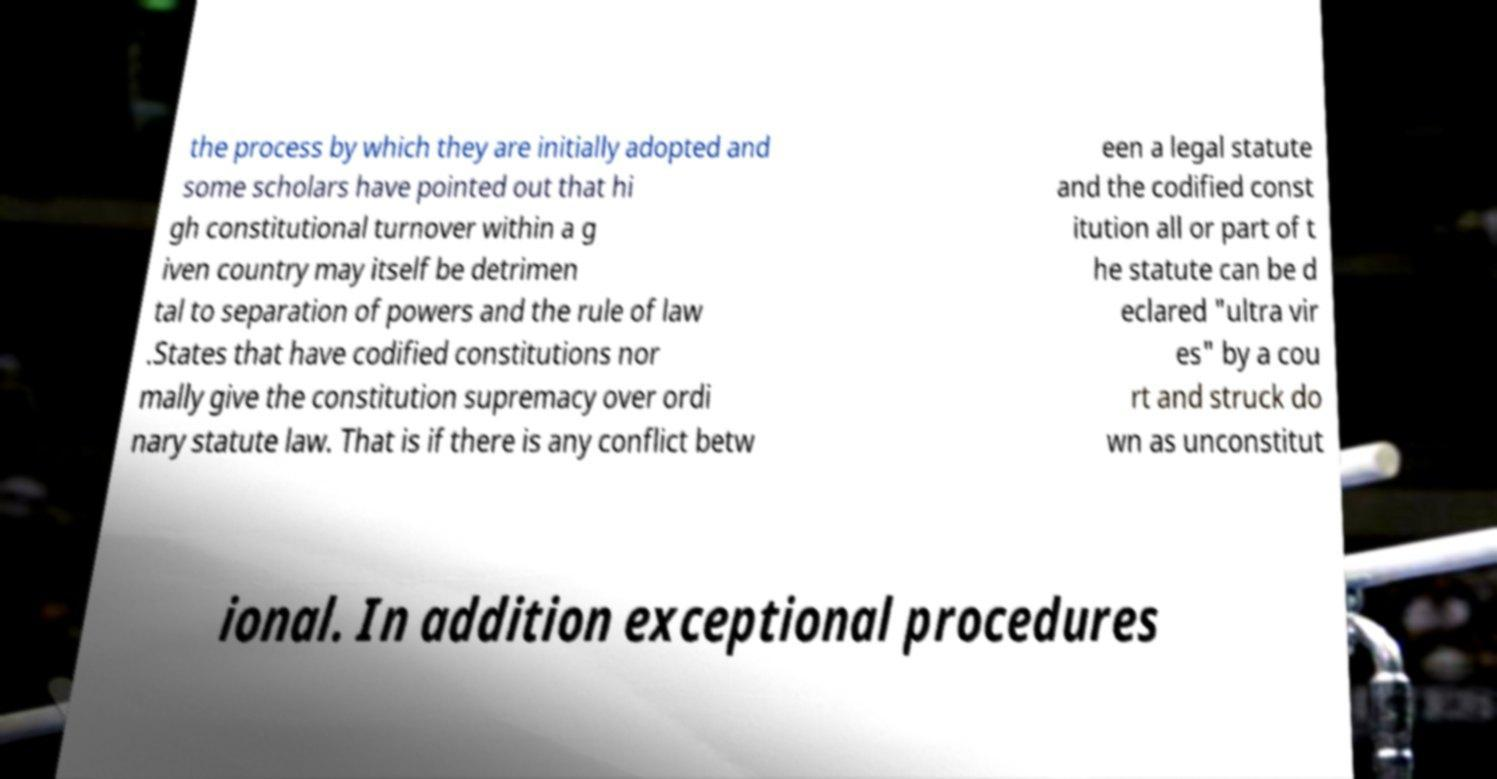I need the written content from this picture converted into text. Can you do that? the process by which they are initially adopted and some scholars have pointed out that hi gh constitutional turnover within a g iven country may itself be detrimen tal to separation of powers and the rule of law .States that have codified constitutions nor mally give the constitution supremacy over ordi nary statute law. That is if there is any conflict betw een a legal statute and the codified const itution all or part of t he statute can be d eclared "ultra vir es" by a cou rt and struck do wn as unconstitut ional. In addition exceptional procedures 